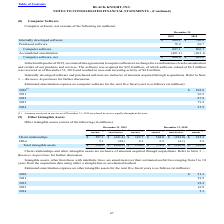According to Black Knight Financial Services's financial document, What did the company do in the fourth quarter of 2019? entered into agreements to acquire software in exchange for a combination of cash consideration and certain of our products and services. The document states: "In the fourth quarter of 2019, we entered into agreements to acquire software in exchange for a combination of cash consideration and certain of our p..." Also, How much did the company acquire software for? According to the financial document, 32.0 (in millions). The relevant text states: "ucts and services. The software was acquired for $32.0 million, of which software valued at $6.5 million was received as of December 31, 2019 and resulted..." Also, What was the amount of internally developed software in 2019? According to the financial document, 808.2 (in millions). The relevant text states: "Internally developed software $ 808.2 $ 746.0..." Also, can you calculate: What was the change in purchased software between 2018 and 2019? Based on the calculation: 78.9-60.7, the result is 18.2 (in millions). This is based on the information: "Purchased software 78.9 60.7 Purchased software 78.9 60.7..." The key data points involved are: 60.7, 78.9. Also, How many years did internally developed software exceed $800 million? Based on the analysis, there are 1 instances. The counting process: 2019. Also, can you calculate: What was the percentage change in net computer software between 2018 and 2019? To answer this question, I need to perform calculations using the financial data. The calculation is: (406.0-405.6)/405.6, which equals 0.1 (percentage). This is based on the information: "Computer software, net $ 406.0 $ 405.6 Computer software, net $ 406.0 $ 405.6..." The key data points involved are: 405.6, 406.0. 